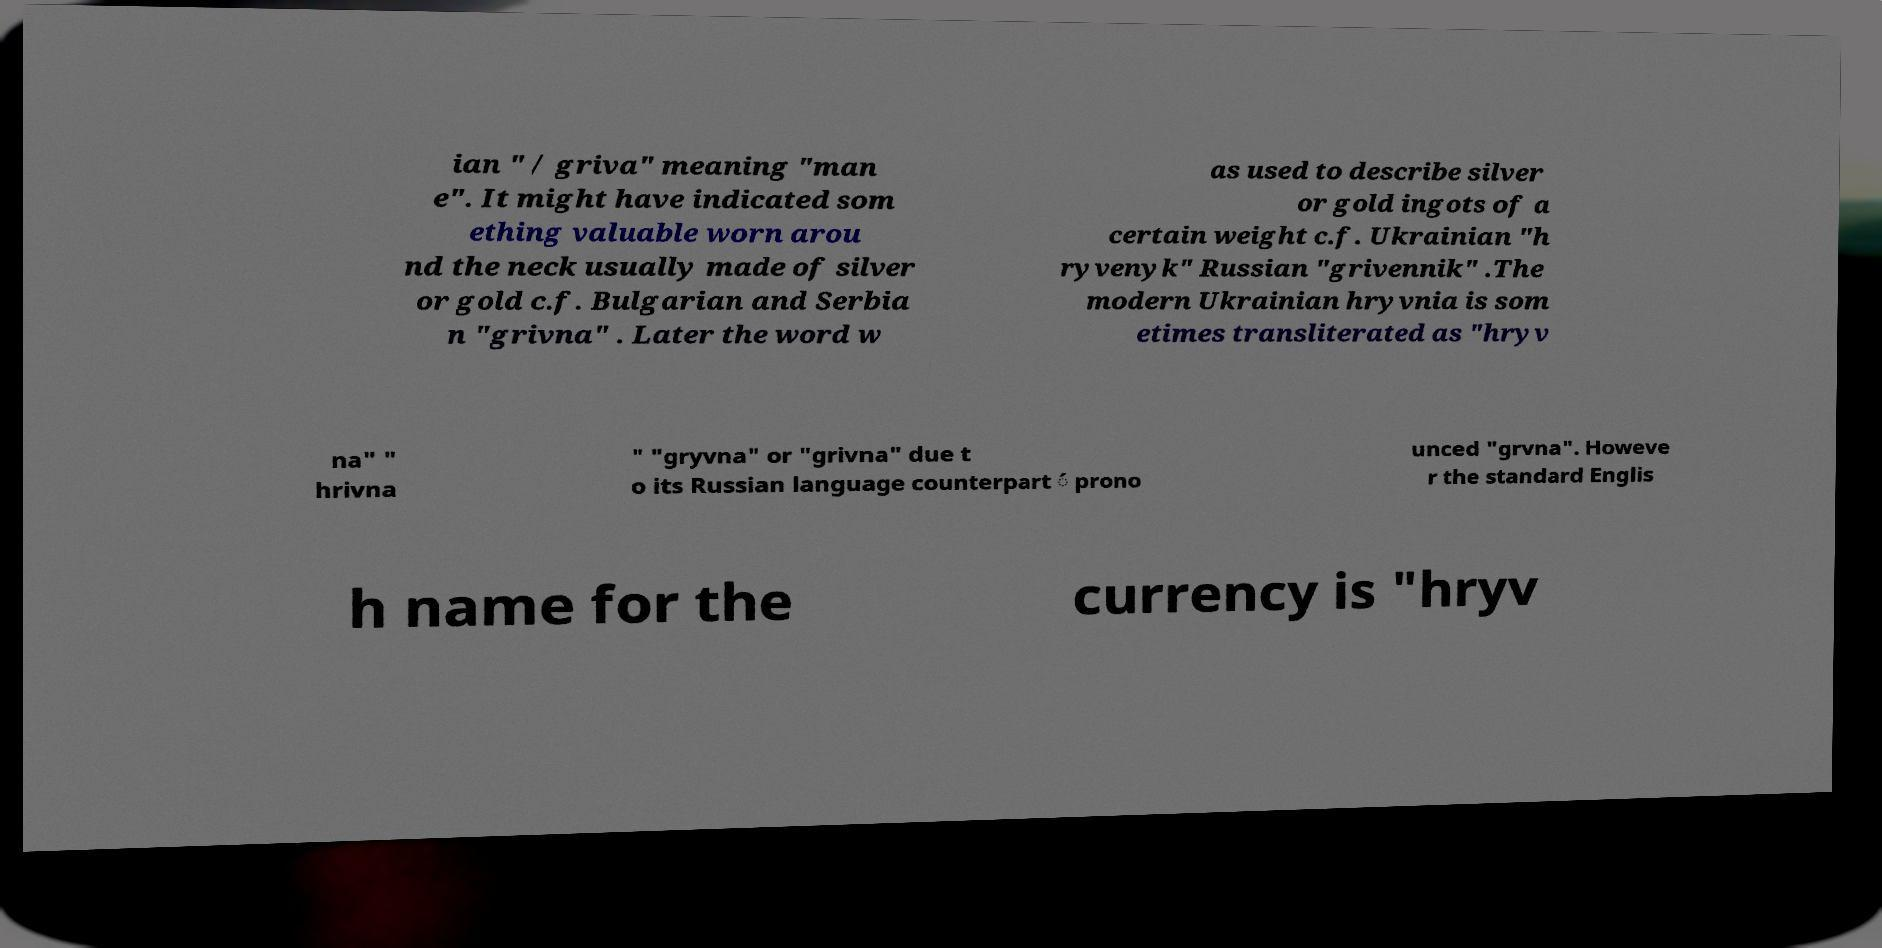What messages or text are displayed in this image? I need them in a readable, typed format. ian " / griva" meaning "man e". It might have indicated som ething valuable worn arou nd the neck usually made of silver or gold c.f. Bulgarian and Serbia n "grivna" . Later the word w as used to describe silver or gold ingots of a certain weight c.f. Ukrainian "h ryvenyk" Russian "grivennik" .The modern Ukrainian hryvnia is som etimes transliterated as "hryv na" " hrivna " "gryvna" or "grivna" due t o its Russian language counterpart ́ prono unced "grvna". Howeve r the standard Englis h name for the currency is "hryv 